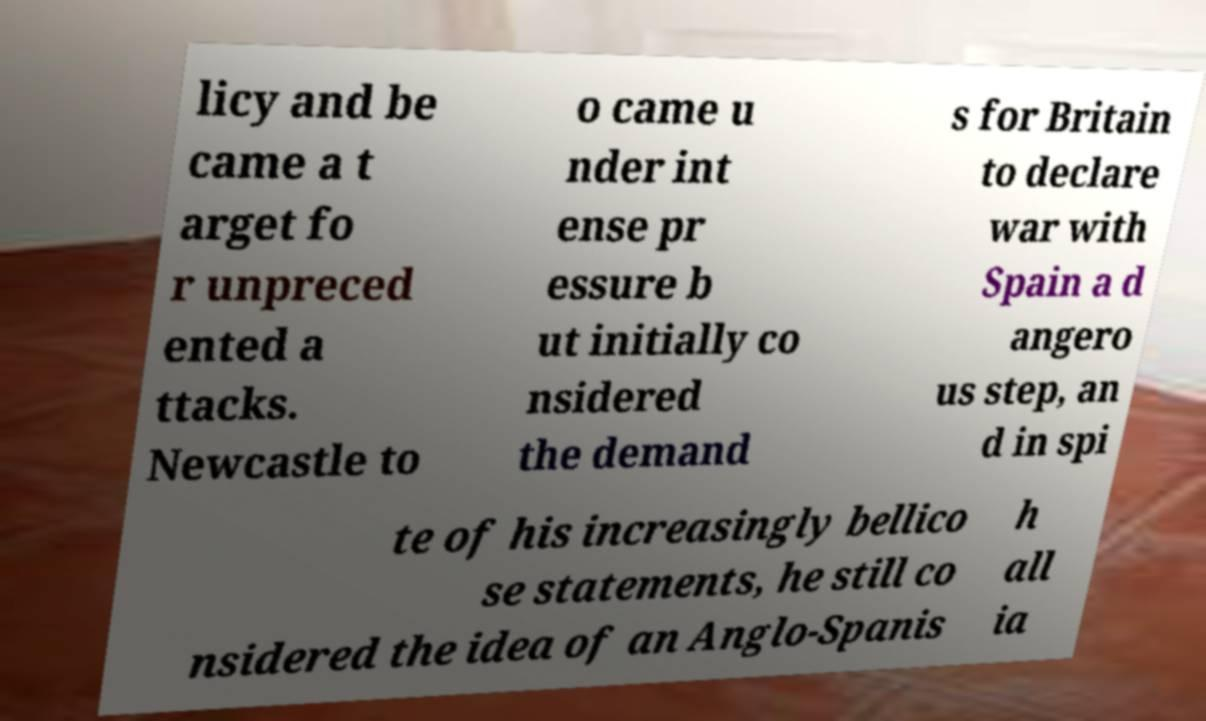Please identify and transcribe the text found in this image. licy and be came a t arget fo r unpreced ented a ttacks. Newcastle to o came u nder int ense pr essure b ut initially co nsidered the demand s for Britain to declare war with Spain a d angero us step, an d in spi te of his increasingly bellico se statements, he still co nsidered the idea of an Anglo-Spanis h all ia 